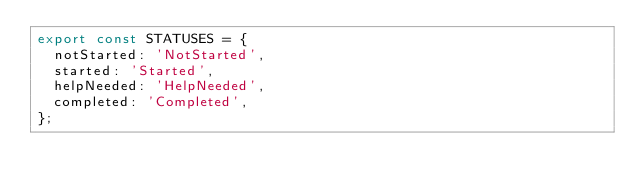Convert code to text. <code><loc_0><loc_0><loc_500><loc_500><_JavaScript_>export const STATUSES = {
  notStarted: 'NotStarted',
  started: 'Started',
  helpNeeded: 'HelpNeeded',
  completed: 'Completed',
};
</code> 